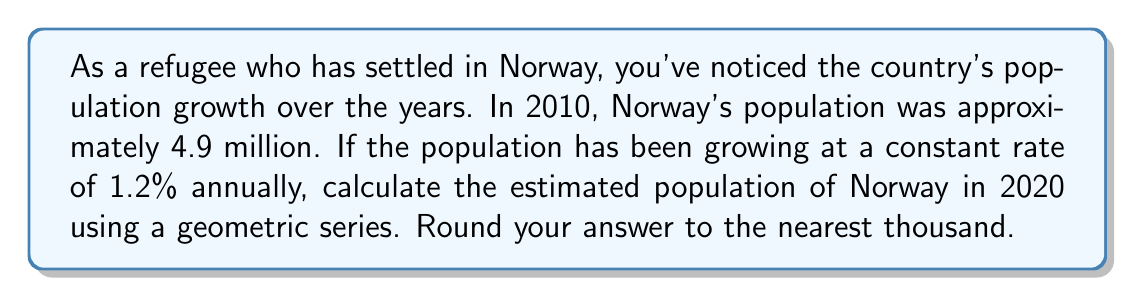What is the answer to this math problem? Let's approach this step-by-step using a geometric series:

1) The initial population (in 2010) is $a = 4.9$ million.
2) The growth rate is 1.2% = 0.012 per year.
3) The common ratio is $r = 1 + 0.012 = 1.012$.
4) We need to calculate for 10 years (2010 to 2020), so $n = 10$.

The formula for the nth term of a geometric sequence is:

$$a_n = a \cdot r^{n-1}$$

Where $a_n$ is the population after n years, $a$ is the initial population, $r$ is the common ratio, and $n$ is the number of years.

Substituting our values:

$$a_{10} = 4.9 \cdot (1.012)^{10-1}$$
$$a_{10} = 4.9 \cdot (1.012)^9$$

Using a calculator:

$$a_{10} = 4.9 \cdot 1.113656$$
$$a_{10} = 5.456914 \text{ million}$$

Rounding to the nearest thousand:

$$a_{10} \approx 5,457,000$$
Answer: 5,457,000 